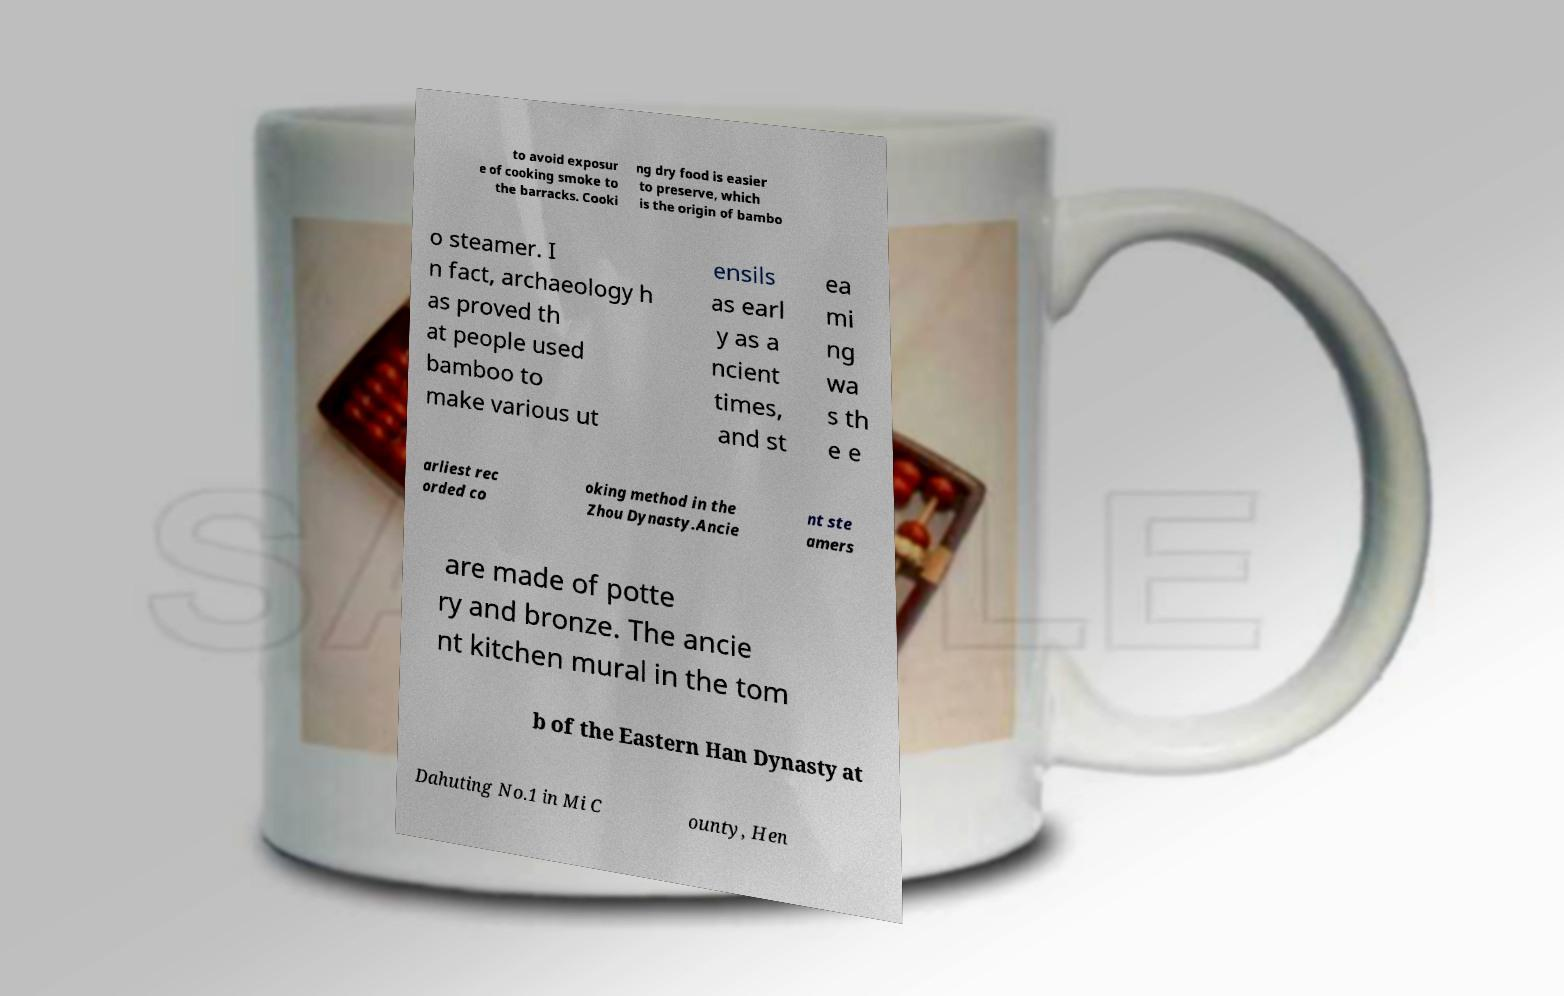I need the written content from this picture converted into text. Can you do that? to avoid exposur e of cooking smoke to the barracks. Cooki ng dry food is easier to preserve, which is the origin of bambo o steamer. I n fact, archaeology h as proved th at people used bamboo to make various ut ensils as earl y as a ncient times, and st ea mi ng wa s th e e arliest rec orded co oking method in the Zhou Dynasty.Ancie nt ste amers are made of potte ry and bronze. The ancie nt kitchen mural in the tom b of the Eastern Han Dynasty at Dahuting No.1 in Mi C ounty, Hen 